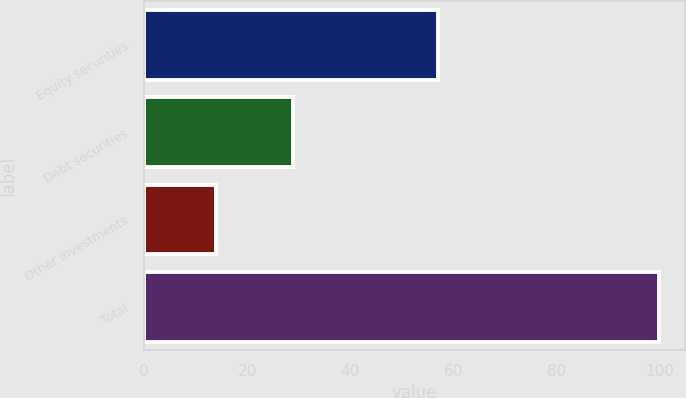Convert chart. <chart><loc_0><loc_0><loc_500><loc_500><bar_chart><fcel>Equity securities<fcel>Debt securities<fcel>Other investments<fcel>Total<nl><fcel>57<fcel>29<fcel>14<fcel>100<nl></chart> 